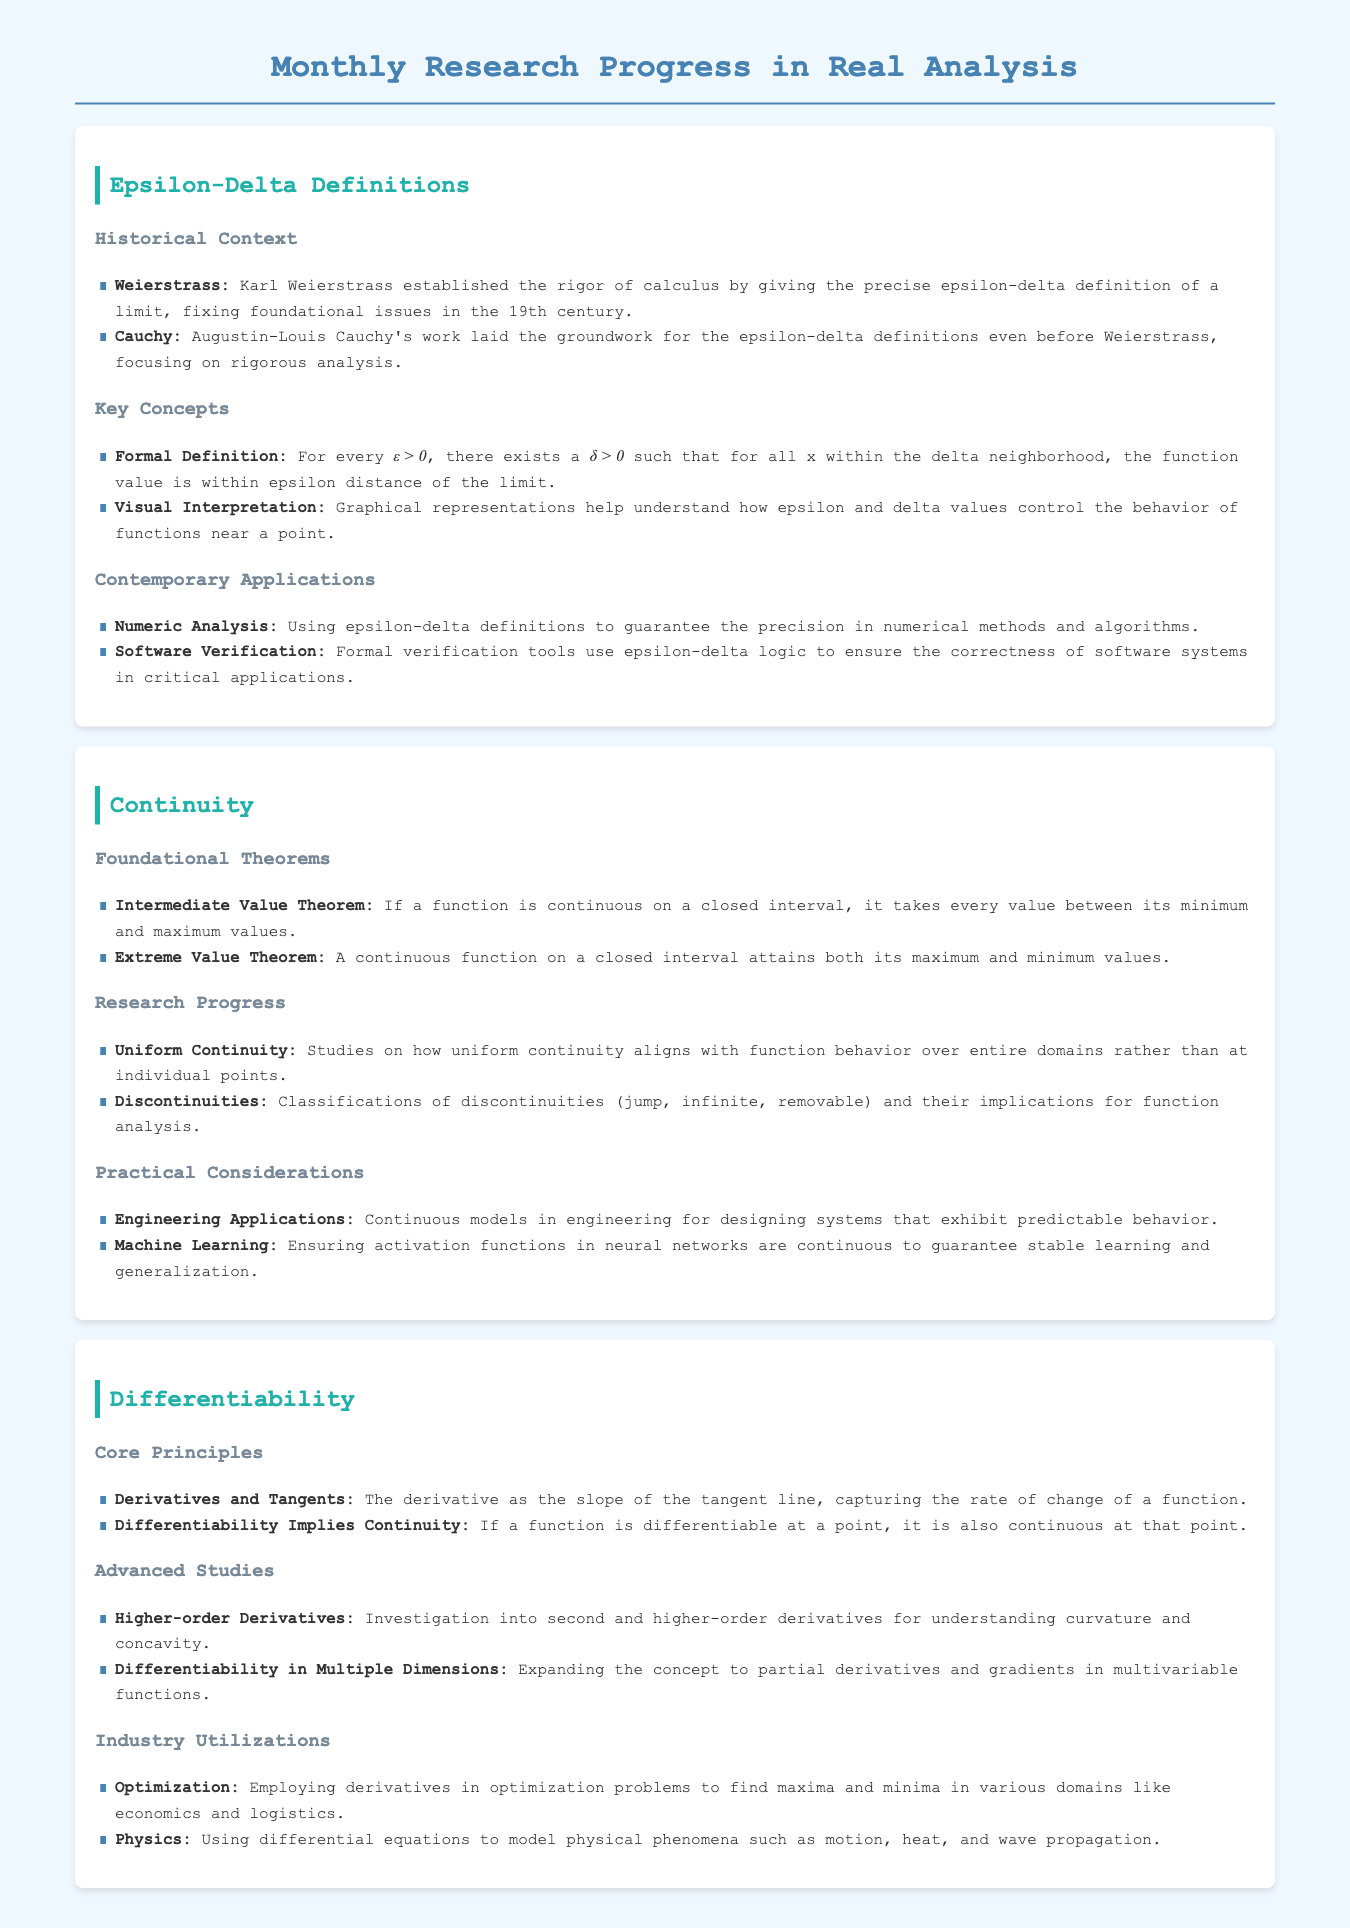What significant contribution did Weierstrass make? Weierstrass established the rigor of calculus by giving the precise epsilon-delta definition of a limit.
Answer: Epsilon-delta definition What does uniform continuity relate to? Uniform continuity discusses function behavior over entire domains rather than at individual points.
Answer: Entire domains What theorem states that a continuous function attains its maximum and minimum values? The Extreme Value Theorem asserts that a continuous function on a closed interval attains both its maximum and minimum values.
Answer: Extreme Value Theorem What does differentiability imply for a function? If a function is differentiable at a point, it is also continuous at that point.
Answer: Continuity What contemporary application uses epsilon-delta definitions? Epsilon-delta definitions are used in software verification tools to ensure correctness.
Answer: Software verification How can derivatives be utilized in optimization problems? Derivatives are employed to find maxima and minima in various domains.
Answer: Maxima and minima 